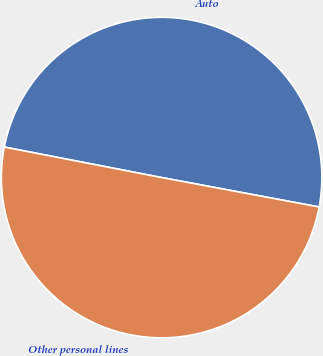<chart> <loc_0><loc_0><loc_500><loc_500><pie_chart><fcel>Auto<fcel>Other personal lines<nl><fcel>49.89%<fcel>50.11%<nl></chart> 